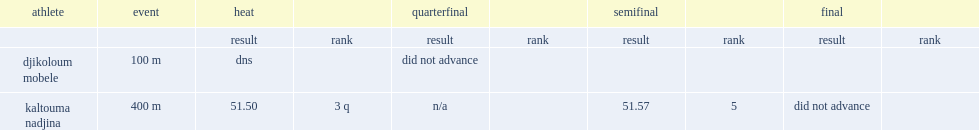What was the result that kaltouma nadjina got in the heat? 51.5. 